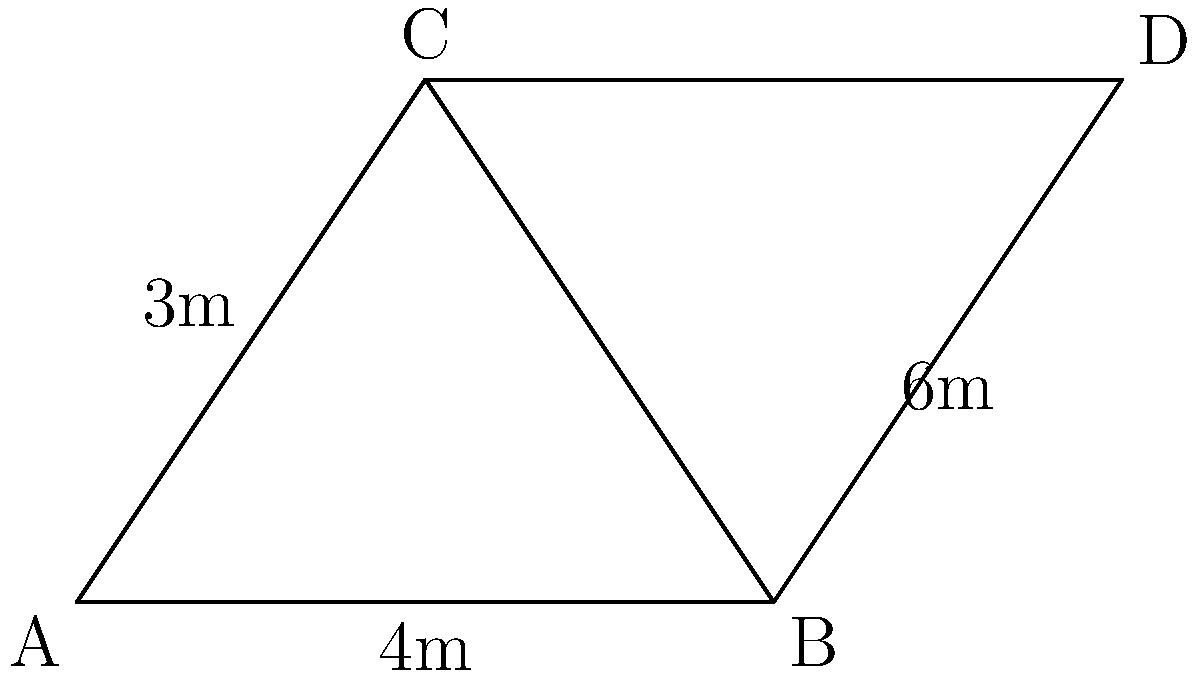For a community event stage design, you need to create two congruent triangular platforms. The existing platform ABC has dimensions AB = 4m, AC = 3m, and BC = 5m. If BD = 6m, what is the length of CD to ensure triangle BCD is congruent to ABC? To solve this problem, we'll use the following steps:

1) First, we need to recognize that for triangles ABC and BCD to be congruent, they must have the same side lengths.

2) We're given that AB = 4m and BD = 6m. These are different, so we can't use the Side-Side-Side (SSS) congruence theorem.

3) However, we know that BC is common to both triangles. This suggests we might use the Side-Angle-Side (SAS) congruence theorem.

4) For SAS, we need two pairs of equal sides and the included angle to be equal.

5) We already have one pair of equal sides (BC is common). We need CD in triangle BCD to equal AC in triangle ABC.

6) We're given that AC = 3m.

7) Therefore, for the triangles to be congruent, CD must also equal 3m.

8) This would satisfy the SAS congruence theorem:
   - BC is common to both triangles
   - AC = CD = 3m
   - The included angle (angle BCA = angle BCD) would be equal if the above conditions are met

Thus, to ensure triangle BCD is congruent to ABC, CD must be 3m long.
Answer: 3m 